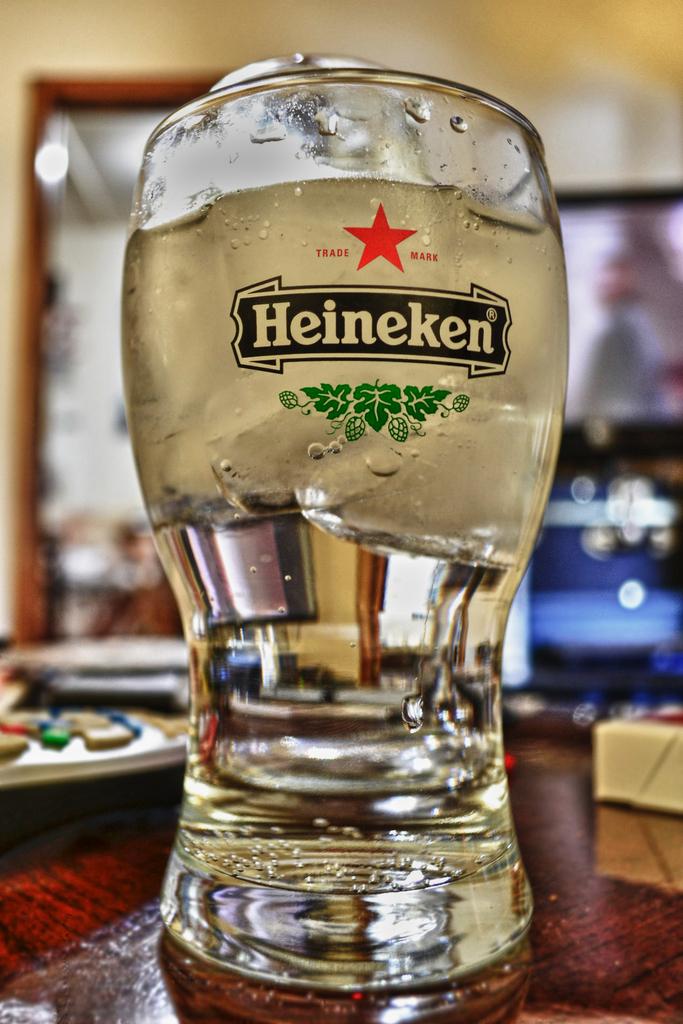Is the drink cold?
Make the answer very short. Yes. 